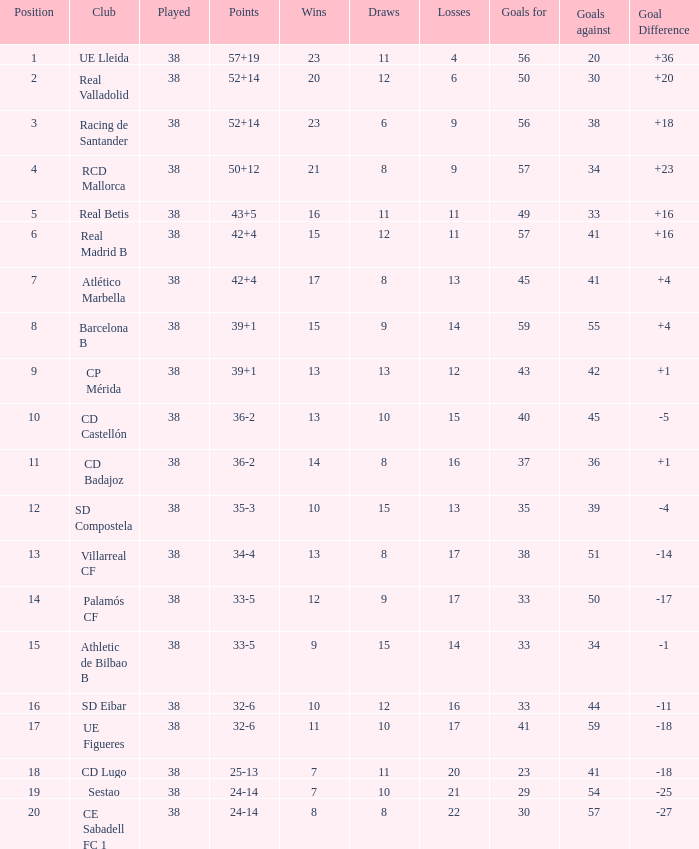Could you parse the entire table as a dict? {'header': ['Position', 'Club', 'Played', 'Points', 'Wins', 'Draws', 'Losses', 'Goals for', 'Goals against', 'Goal Difference'], 'rows': [['1', 'UE Lleida', '38', '57+19', '23', '11', '4', '56', '20', '+36'], ['2', 'Real Valladolid', '38', '52+14', '20', '12', '6', '50', '30', '+20'], ['3', 'Racing de Santander', '38', '52+14', '23', '6', '9', '56', '38', '+18'], ['4', 'RCD Mallorca', '38', '50+12', '21', '8', '9', '57', '34', '+23'], ['5', 'Real Betis', '38', '43+5', '16', '11', '11', '49', '33', '+16'], ['6', 'Real Madrid B', '38', '42+4', '15', '12', '11', '57', '41', '+16'], ['7', 'Atlético Marbella', '38', '42+4', '17', '8', '13', '45', '41', '+4'], ['8', 'Barcelona B', '38', '39+1', '15', '9', '14', '59', '55', '+4'], ['9', 'CP Mérida', '38', '39+1', '13', '13', '12', '43', '42', '+1'], ['10', 'CD Castellón', '38', '36-2', '13', '10', '15', '40', '45', '-5'], ['11', 'CD Badajoz', '38', '36-2', '14', '8', '16', '37', '36', '+1'], ['12', 'SD Compostela', '38', '35-3', '10', '15', '13', '35', '39', '-4'], ['13', 'Villarreal CF', '38', '34-4', '13', '8', '17', '38', '51', '-14'], ['14', 'Palamós CF', '38', '33-5', '12', '9', '17', '33', '50', '-17'], ['15', 'Athletic de Bilbao B', '38', '33-5', '9', '15', '14', '33', '34', '-1'], ['16', 'SD Eibar', '38', '32-6', '10', '12', '16', '33', '44', '-11'], ['17', 'UE Figueres', '38', '32-6', '11', '10', '17', '41', '59', '-18'], ['18', 'CD Lugo', '38', '25-13', '7', '11', '20', '23', '41', '-18'], ['19', 'Sestao', '38', '24-14', '7', '10', '21', '29', '54', '-25'], ['20', 'CE Sabadell FC 1', '38', '24-14', '8', '8', '22', '30', '57', '-27']]} What is the maximum standing with fewer than 17 losses, in excess of 57 goals, and a goal difference below 4? None. 